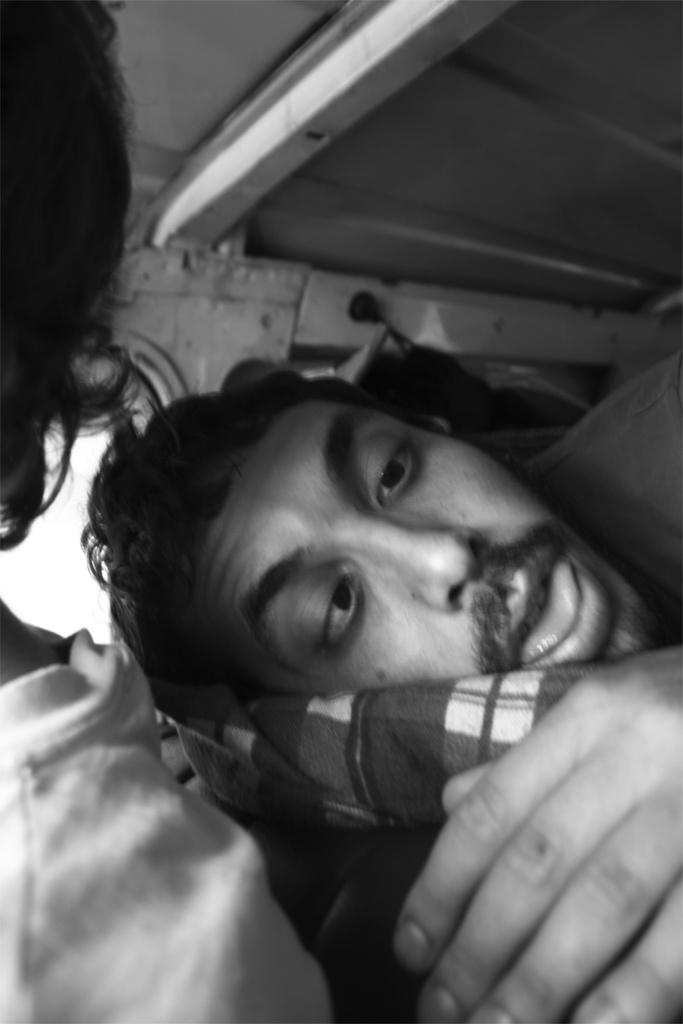What type of living organisms can be seen in the image? There are humans in the image. What is visible in the background of the image? There is a wall in the background of the image. What type of plants can be seen growing in the bucket in the image? There is no bucket or plants present in the image. What country is depicted in the image? The image does not depict a specific country; it only shows humans and a wall. 